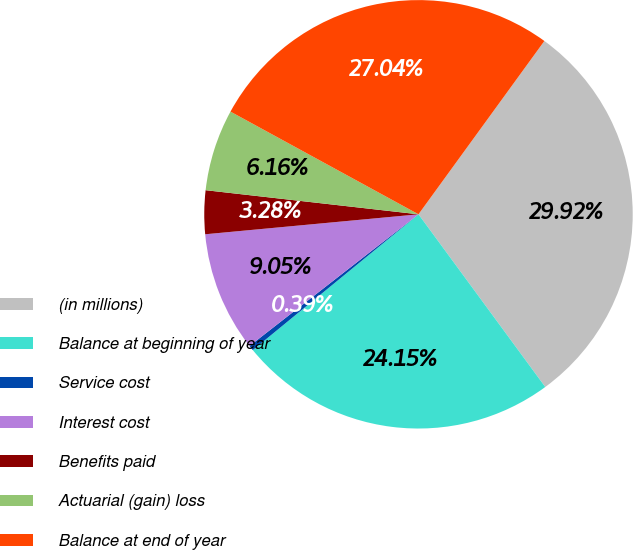<chart> <loc_0><loc_0><loc_500><loc_500><pie_chart><fcel>(in millions)<fcel>Balance at beginning of year<fcel>Service cost<fcel>Interest cost<fcel>Benefits paid<fcel>Actuarial (gain) loss<fcel>Balance at end of year<nl><fcel>29.92%<fcel>24.15%<fcel>0.39%<fcel>9.05%<fcel>3.28%<fcel>6.16%<fcel>27.04%<nl></chart> 